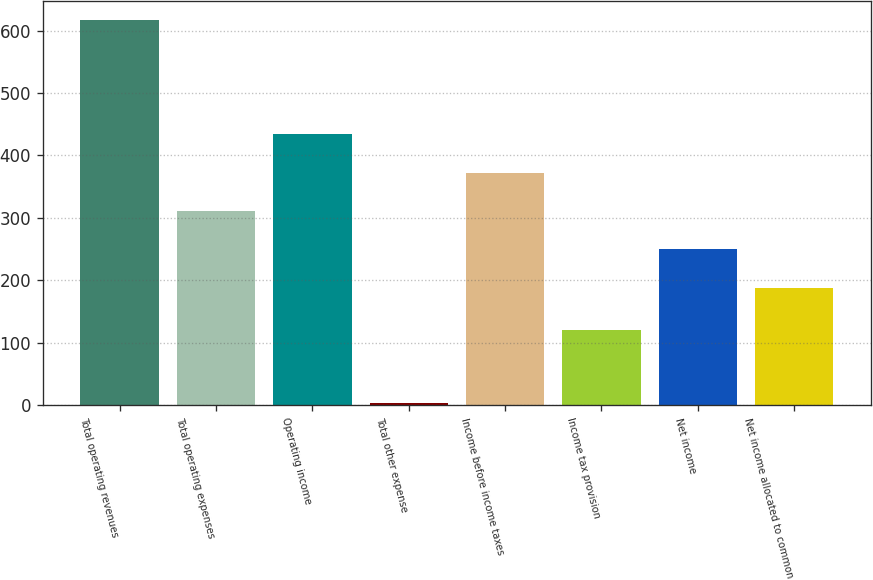Convert chart to OTSL. <chart><loc_0><loc_0><loc_500><loc_500><bar_chart><fcel>Total operating revenues<fcel>Total operating expenses<fcel>Operating income<fcel>Total other expense<fcel>Income before income taxes<fcel>Income tax provision<fcel>Net income<fcel>Net income allocated to common<nl><fcel>617.2<fcel>311.02<fcel>433.64<fcel>4.1<fcel>372.33<fcel>120<fcel>249.71<fcel>188.4<nl></chart> 